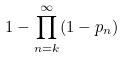<formula> <loc_0><loc_0><loc_500><loc_500>1 - \prod _ { n = k } ^ { \infty } ( 1 - p _ { n } )</formula> 